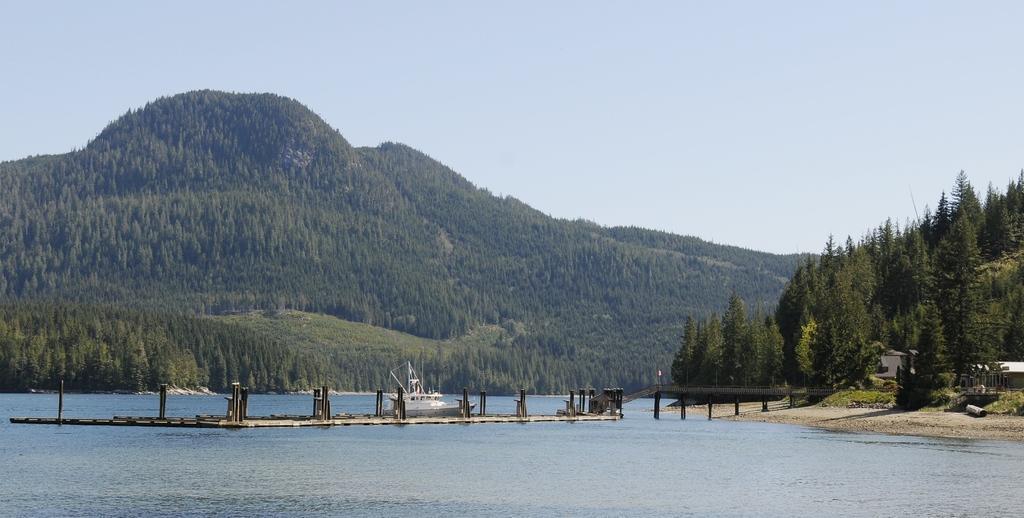Could you give a brief overview of what you see in this image? In this image we can see a boat place on the water. To the right side of the image we can see a bridge ,group of trees ,buildings. In the background we can see mountain and sky. In the foreground we can see water. 